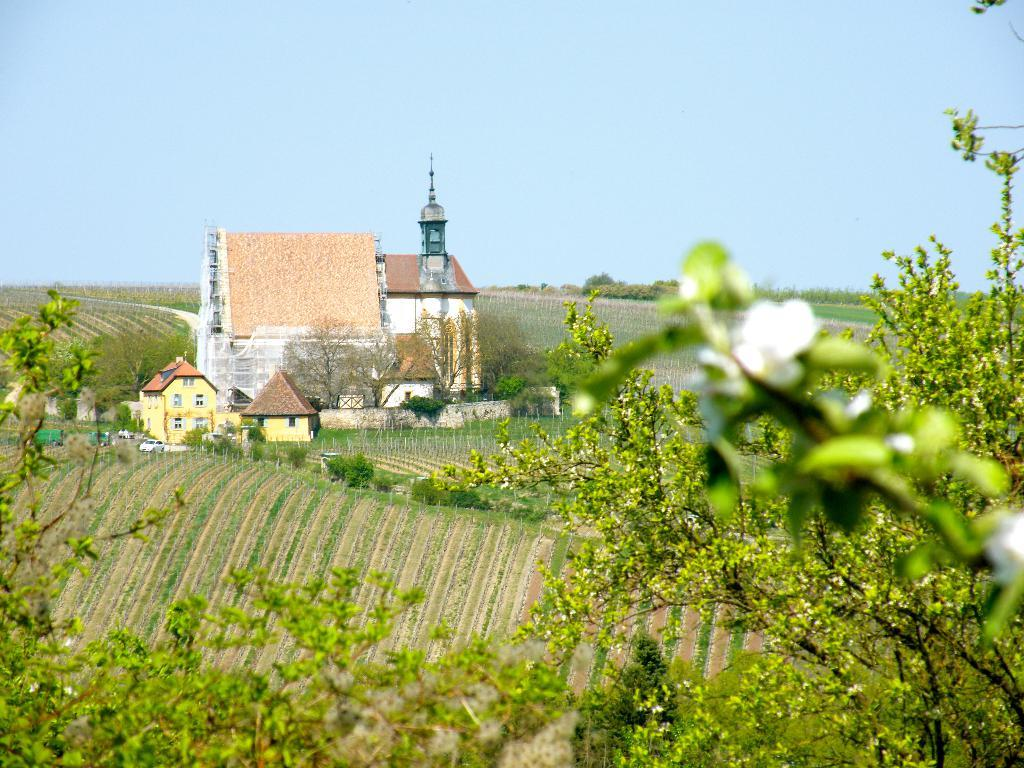What type of structures can be seen in the image? There are buildings in the image. What other natural elements are present in the image? There are trees and plants in the image. What mode of transportation can be seen on the road in the image? There are vehicles on the road in the image. What are the tall, thin objects in the image? There are poles in the image. What is visible at the top of the image? The sky is visible at the top of the image. What year is depicted in the image? The image does not depict a specific year; it is a general scene with buildings, trees, plants, vehicles, poles, and the sky. What is the material used to make the poles in the image? The image does not specify the material used to make the poles; it only shows their presence. 